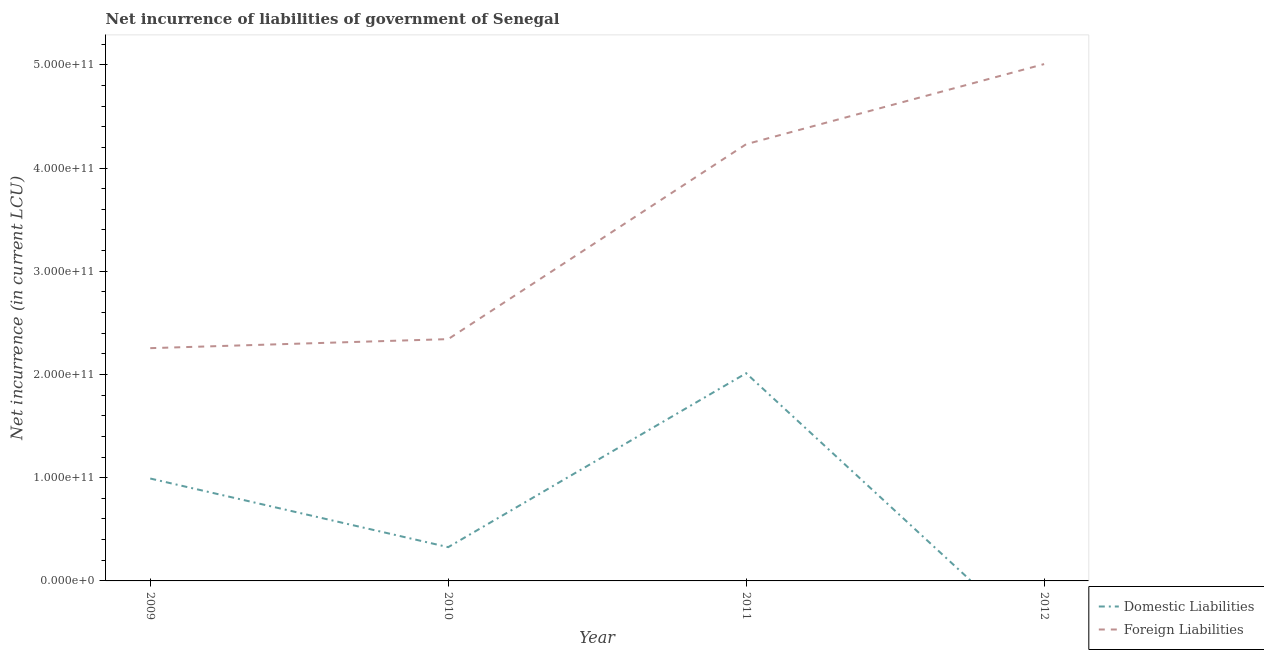How many different coloured lines are there?
Provide a succinct answer. 2. What is the net incurrence of domestic liabilities in 2011?
Your answer should be very brief. 2.01e+11. Across all years, what is the maximum net incurrence of foreign liabilities?
Provide a succinct answer. 5.01e+11. Across all years, what is the minimum net incurrence of foreign liabilities?
Your answer should be very brief. 2.26e+11. What is the total net incurrence of domestic liabilities in the graph?
Make the answer very short. 3.33e+11. What is the difference between the net incurrence of foreign liabilities in 2011 and that in 2012?
Your response must be concise. -7.76e+1. What is the difference between the net incurrence of foreign liabilities in 2009 and the net incurrence of domestic liabilities in 2010?
Your answer should be very brief. 1.93e+11. What is the average net incurrence of domestic liabilities per year?
Your answer should be compact. 8.33e+1. In the year 2010, what is the difference between the net incurrence of domestic liabilities and net incurrence of foreign liabilities?
Provide a short and direct response. -2.02e+11. In how many years, is the net incurrence of domestic liabilities greater than 20000000000 LCU?
Ensure brevity in your answer.  3. What is the ratio of the net incurrence of foreign liabilities in 2009 to that in 2012?
Provide a succinct answer. 0.45. What is the difference between the highest and the second highest net incurrence of foreign liabilities?
Offer a very short reply. 7.76e+1. What is the difference between the highest and the lowest net incurrence of foreign liabilities?
Provide a succinct answer. 2.75e+11. Does the net incurrence of domestic liabilities monotonically increase over the years?
Offer a terse response. No. Is the net incurrence of foreign liabilities strictly greater than the net incurrence of domestic liabilities over the years?
Provide a succinct answer. Yes. Is the net incurrence of domestic liabilities strictly less than the net incurrence of foreign liabilities over the years?
Keep it short and to the point. Yes. What is the difference between two consecutive major ticks on the Y-axis?
Provide a short and direct response. 1.00e+11. Are the values on the major ticks of Y-axis written in scientific E-notation?
Make the answer very short. Yes. Does the graph contain any zero values?
Offer a very short reply. Yes. How many legend labels are there?
Offer a terse response. 2. How are the legend labels stacked?
Keep it short and to the point. Vertical. What is the title of the graph?
Keep it short and to the point. Net incurrence of liabilities of government of Senegal. Does "Exports of goods" appear as one of the legend labels in the graph?
Your answer should be very brief. No. What is the label or title of the X-axis?
Give a very brief answer. Year. What is the label or title of the Y-axis?
Your answer should be compact. Net incurrence (in current LCU). What is the Net incurrence (in current LCU) in Domestic Liabilities in 2009?
Your answer should be very brief. 9.92e+1. What is the Net incurrence (in current LCU) of Foreign Liabilities in 2009?
Your answer should be compact. 2.26e+11. What is the Net incurrence (in current LCU) of Domestic Liabilities in 2010?
Offer a very short reply. 3.27e+1. What is the Net incurrence (in current LCU) in Foreign Liabilities in 2010?
Make the answer very short. 2.34e+11. What is the Net incurrence (in current LCU) of Domestic Liabilities in 2011?
Keep it short and to the point. 2.01e+11. What is the Net incurrence (in current LCU) of Foreign Liabilities in 2011?
Offer a terse response. 4.23e+11. What is the Net incurrence (in current LCU) of Foreign Liabilities in 2012?
Offer a very short reply. 5.01e+11. Across all years, what is the maximum Net incurrence (in current LCU) in Domestic Liabilities?
Give a very brief answer. 2.01e+11. Across all years, what is the maximum Net incurrence (in current LCU) in Foreign Liabilities?
Ensure brevity in your answer.  5.01e+11. Across all years, what is the minimum Net incurrence (in current LCU) of Foreign Liabilities?
Your answer should be very brief. 2.26e+11. What is the total Net incurrence (in current LCU) of Domestic Liabilities in the graph?
Give a very brief answer. 3.33e+11. What is the total Net incurrence (in current LCU) in Foreign Liabilities in the graph?
Offer a terse response. 1.38e+12. What is the difference between the Net incurrence (in current LCU) of Domestic Liabilities in 2009 and that in 2010?
Make the answer very short. 6.65e+1. What is the difference between the Net incurrence (in current LCU) of Foreign Liabilities in 2009 and that in 2010?
Your response must be concise. -8.75e+09. What is the difference between the Net incurrence (in current LCU) of Domestic Liabilities in 2009 and that in 2011?
Your response must be concise. -1.02e+11. What is the difference between the Net incurrence (in current LCU) in Foreign Liabilities in 2009 and that in 2011?
Your response must be concise. -1.98e+11. What is the difference between the Net incurrence (in current LCU) in Foreign Liabilities in 2009 and that in 2012?
Make the answer very short. -2.75e+11. What is the difference between the Net incurrence (in current LCU) of Domestic Liabilities in 2010 and that in 2011?
Keep it short and to the point. -1.68e+11. What is the difference between the Net incurrence (in current LCU) of Foreign Liabilities in 2010 and that in 2011?
Offer a terse response. -1.89e+11. What is the difference between the Net incurrence (in current LCU) in Foreign Liabilities in 2010 and that in 2012?
Provide a succinct answer. -2.66e+11. What is the difference between the Net incurrence (in current LCU) of Foreign Liabilities in 2011 and that in 2012?
Make the answer very short. -7.76e+1. What is the difference between the Net incurrence (in current LCU) of Domestic Liabilities in 2009 and the Net incurrence (in current LCU) of Foreign Liabilities in 2010?
Make the answer very short. -1.35e+11. What is the difference between the Net incurrence (in current LCU) in Domestic Liabilities in 2009 and the Net incurrence (in current LCU) in Foreign Liabilities in 2011?
Provide a short and direct response. -3.24e+11. What is the difference between the Net incurrence (in current LCU) in Domestic Liabilities in 2009 and the Net incurrence (in current LCU) in Foreign Liabilities in 2012?
Make the answer very short. -4.02e+11. What is the difference between the Net incurrence (in current LCU) of Domestic Liabilities in 2010 and the Net incurrence (in current LCU) of Foreign Liabilities in 2011?
Provide a short and direct response. -3.90e+11. What is the difference between the Net incurrence (in current LCU) of Domestic Liabilities in 2010 and the Net incurrence (in current LCU) of Foreign Liabilities in 2012?
Ensure brevity in your answer.  -4.68e+11. What is the difference between the Net incurrence (in current LCU) in Domestic Liabilities in 2011 and the Net incurrence (in current LCU) in Foreign Liabilities in 2012?
Provide a succinct answer. -3.00e+11. What is the average Net incurrence (in current LCU) of Domestic Liabilities per year?
Keep it short and to the point. 8.33e+1. What is the average Net incurrence (in current LCU) in Foreign Liabilities per year?
Make the answer very short. 3.46e+11. In the year 2009, what is the difference between the Net incurrence (in current LCU) in Domestic Liabilities and Net incurrence (in current LCU) in Foreign Liabilities?
Provide a short and direct response. -1.26e+11. In the year 2010, what is the difference between the Net incurrence (in current LCU) in Domestic Liabilities and Net incurrence (in current LCU) in Foreign Liabilities?
Your answer should be compact. -2.02e+11. In the year 2011, what is the difference between the Net incurrence (in current LCU) of Domestic Liabilities and Net incurrence (in current LCU) of Foreign Liabilities?
Provide a short and direct response. -2.22e+11. What is the ratio of the Net incurrence (in current LCU) in Domestic Liabilities in 2009 to that in 2010?
Make the answer very short. 3.03. What is the ratio of the Net incurrence (in current LCU) of Foreign Liabilities in 2009 to that in 2010?
Offer a very short reply. 0.96. What is the ratio of the Net incurrence (in current LCU) of Domestic Liabilities in 2009 to that in 2011?
Your response must be concise. 0.49. What is the ratio of the Net incurrence (in current LCU) in Foreign Liabilities in 2009 to that in 2011?
Keep it short and to the point. 0.53. What is the ratio of the Net incurrence (in current LCU) in Foreign Liabilities in 2009 to that in 2012?
Provide a succinct answer. 0.45. What is the ratio of the Net incurrence (in current LCU) in Domestic Liabilities in 2010 to that in 2011?
Offer a very short reply. 0.16. What is the ratio of the Net incurrence (in current LCU) in Foreign Liabilities in 2010 to that in 2011?
Your response must be concise. 0.55. What is the ratio of the Net incurrence (in current LCU) of Foreign Liabilities in 2010 to that in 2012?
Offer a very short reply. 0.47. What is the ratio of the Net incurrence (in current LCU) in Foreign Liabilities in 2011 to that in 2012?
Your answer should be very brief. 0.84. What is the difference between the highest and the second highest Net incurrence (in current LCU) in Domestic Liabilities?
Your response must be concise. 1.02e+11. What is the difference between the highest and the second highest Net incurrence (in current LCU) of Foreign Liabilities?
Provide a short and direct response. 7.76e+1. What is the difference between the highest and the lowest Net incurrence (in current LCU) of Domestic Liabilities?
Offer a very short reply. 2.01e+11. What is the difference between the highest and the lowest Net incurrence (in current LCU) in Foreign Liabilities?
Your response must be concise. 2.75e+11. 